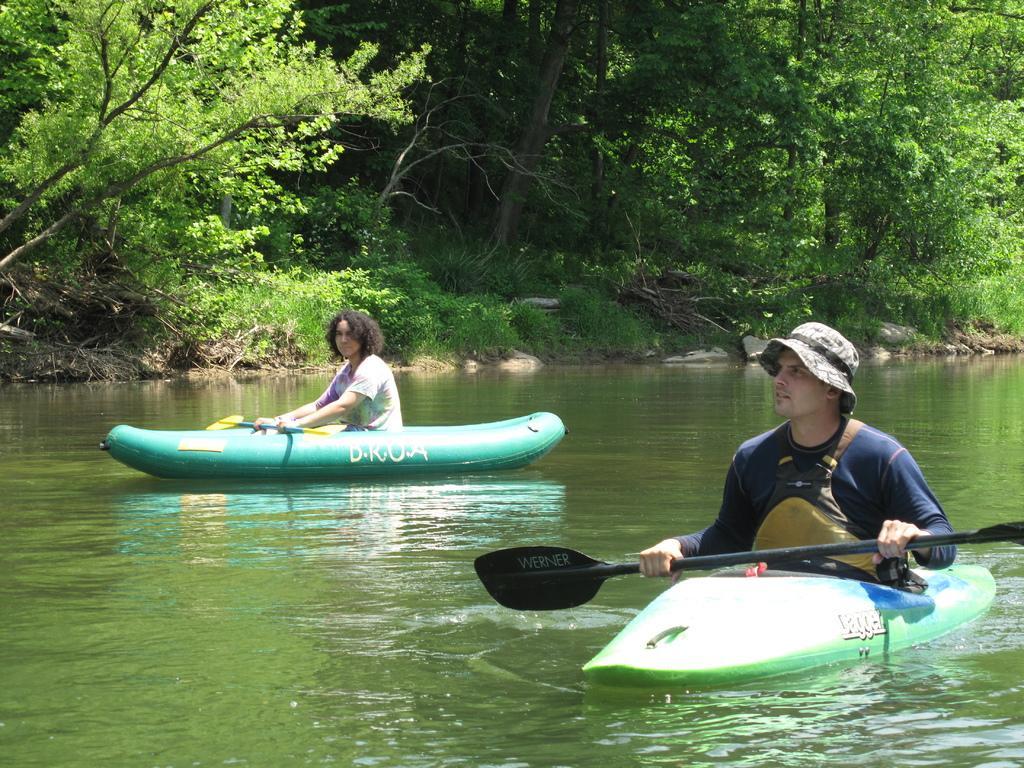In one or two sentences, can you explain what this image depicts? This image is taken outdoors. In the background there are many trees and plants on the ground. At the bottom of the image there is a lake with water. In the middle of the image two men are sitting in the boats and they are sailing on the lake. They are holding boat pads in their hands. 